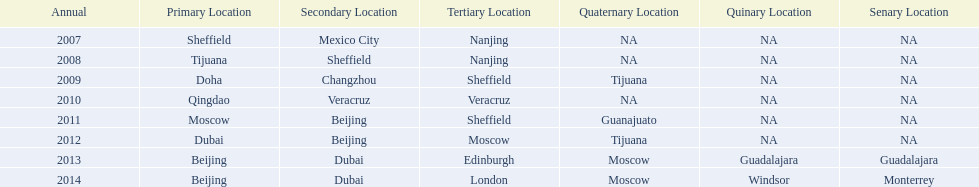In list of venues, how many years was beijing above moscow (1st venue is above 2nd venue, etc)? 3. 